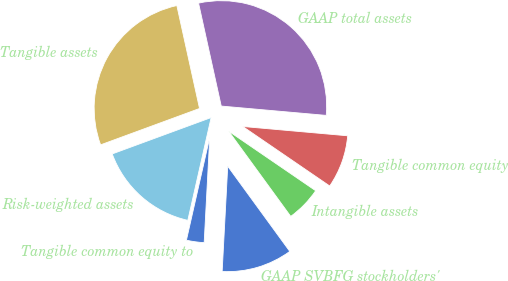<chart> <loc_0><loc_0><loc_500><loc_500><pie_chart><fcel>GAAP SVBFG stockholders'<fcel>Intangible assets<fcel>Tangible common equity<fcel>GAAP total assets<fcel>Tangible assets<fcel>Risk-weighted assets<fcel>Tangible common equity to<nl><fcel>10.86%<fcel>5.43%<fcel>8.14%<fcel>29.86%<fcel>27.15%<fcel>15.84%<fcel>2.71%<nl></chart> 